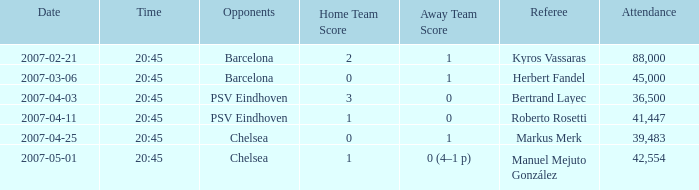WHAT OPPONENT HAD A KICKOFF OF 2007-03-06, 20:45? Barcelona. 